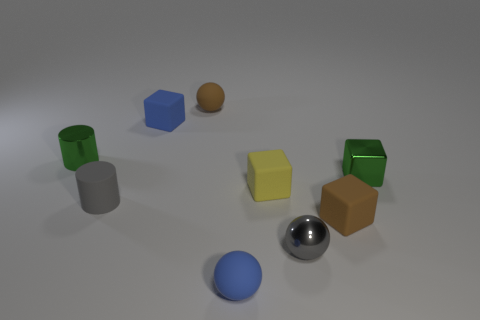The small yellow thing has what shape?
Make the answer very short. Cube. What material is the brown cube that is the same size as the green metallic block?
Your response must be concise. Rubber. How many big things are green metallic balls or green shiny cylinders?
Your answer should be very brief. 0. Is there a large blue matte sphere?
Offer a terse response. No. There is a yellow block that is made of the same material as the blue sphere; what is its size?
Your answer should be very brief. Small. Is the gray cylinder made of the same material as the small green block?
Make the answer very short. No. What number of other objects are there of the same material as the tiny brown sphere?
Offer a very short reply. 5. How many tiny green metallic things are to the right of the gray matte cylinder and left of the small brown matte ball?
Your answer should be compact. 0. What is the color of the metal cube?
Provide a short and direct response. Green. There is a blue object that is the same shape as the tiny yellow rubber thing; what is its material?
Make the answer very short. Rubber. 